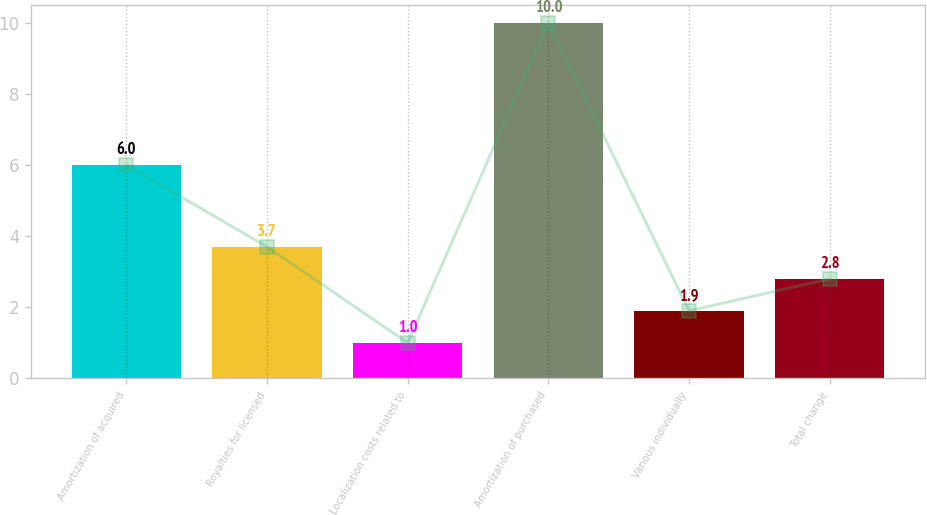<chart> <loc_0><loc_0><loc_500><loc_500><bar_chart><fcel>Amortization of acquired<fcel>Royalties for licensed<fcel>Localization costs related to<fcel>Amortization of purchased<fcel>Various individually<fcel>Total change<nl><fcel>6<fcel>3.7<fcel>1<fcel>10<fcel>1.9<fcel>2.8<nl></chart> 